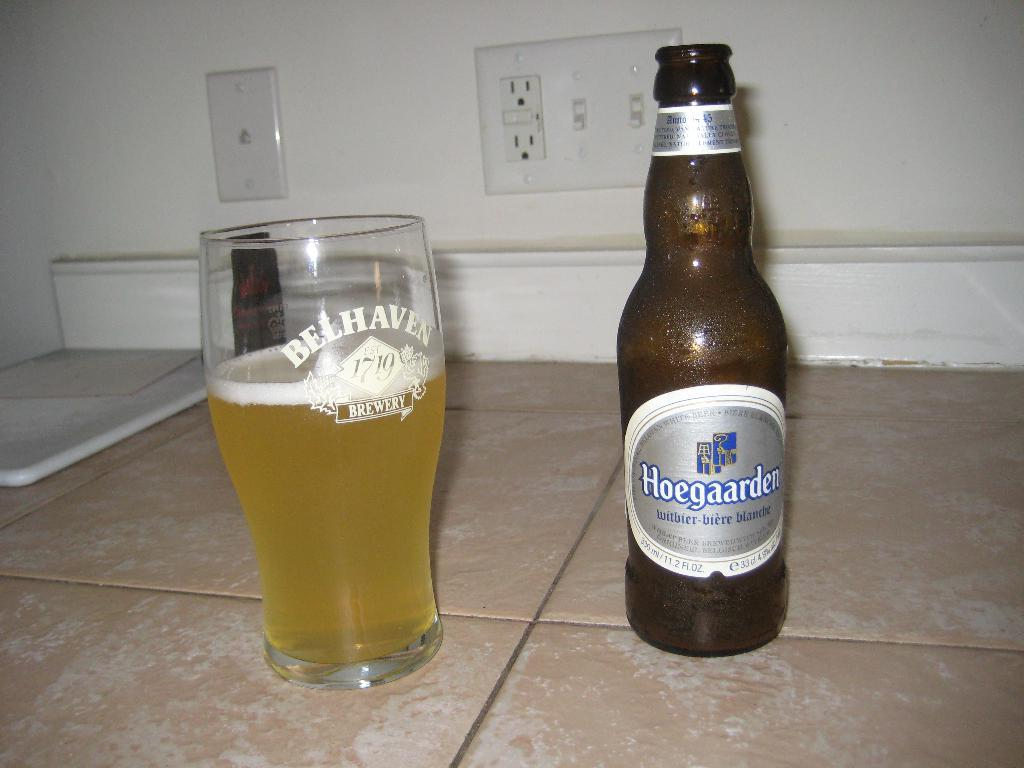<image>
Relay a brief, clear account of the picture shown. A glass that says Belhaven sitting next to a bottle of beer. 